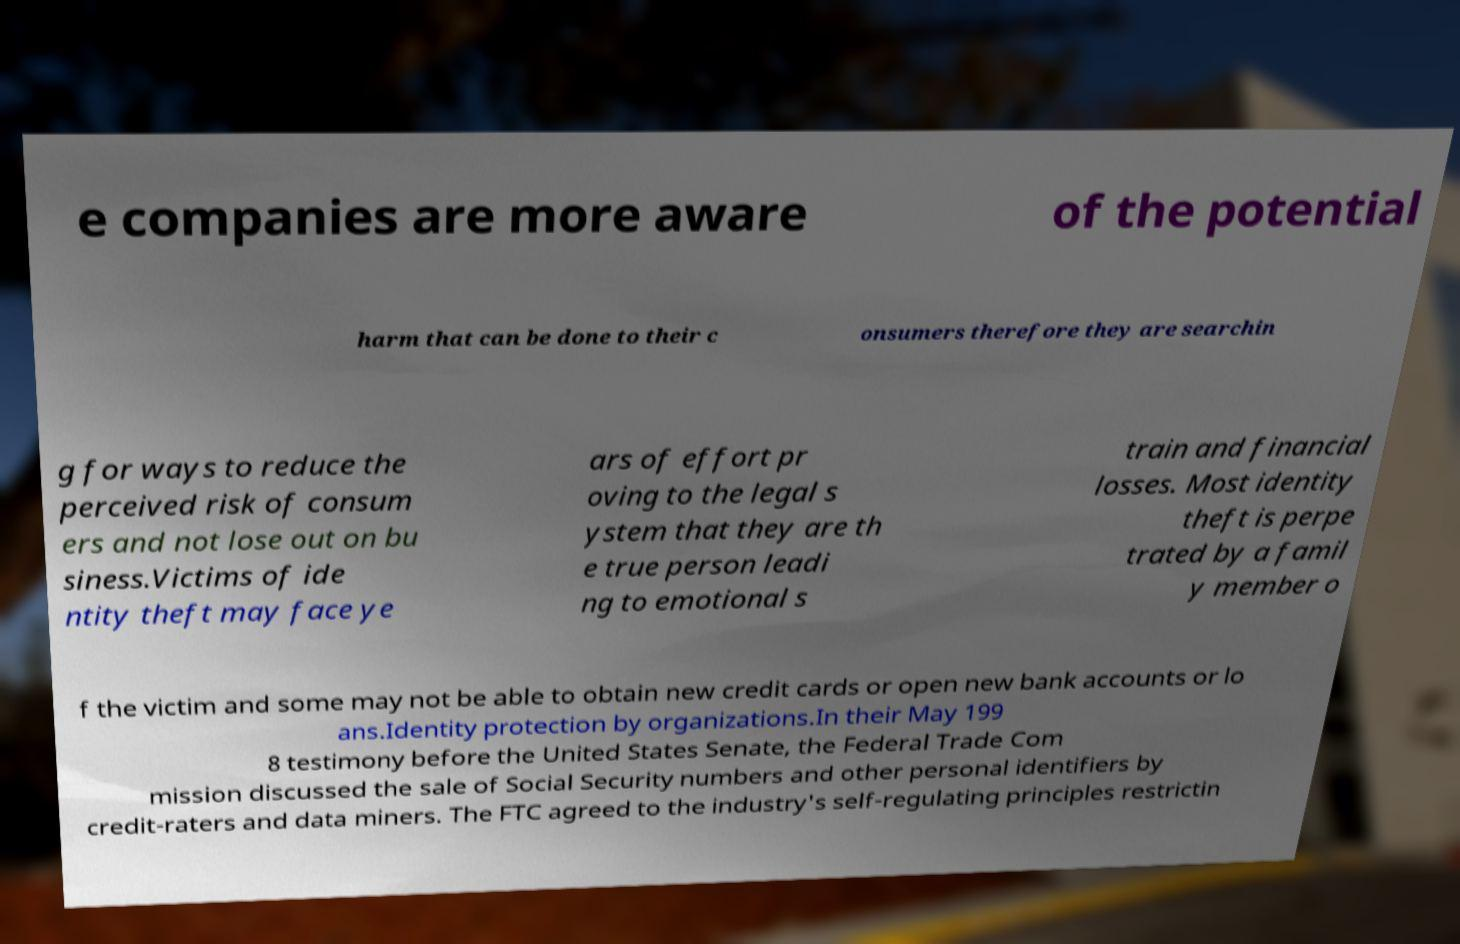Could you assist in decoding the text presented in this image and type it out clearly? e companies are more aware of the potential harm that can be done to their c onsumers therefore they are searchin g for ways to reduce the perceived risk of consum ers and not lose out on bu siness.Victims of ide ntity theft may face ye ars of effort pr oving to the legal s ystem that they are th e true person leadi ng to emotional s train and financial losses. Most identity theft is perpe trated by a famil y member o f the victim and some may not be able to obtain new credit cards or open new bank accounts or lo ans.Identity protection by organizations.In their May 199 8 testimony before the United States Senate, the Federal Trade Com mission discussed the sale of Social Security numbers and other personal identifiers by credit-raters and data miners. The FTC agreed to the industry's self-regulating principles restrictin 